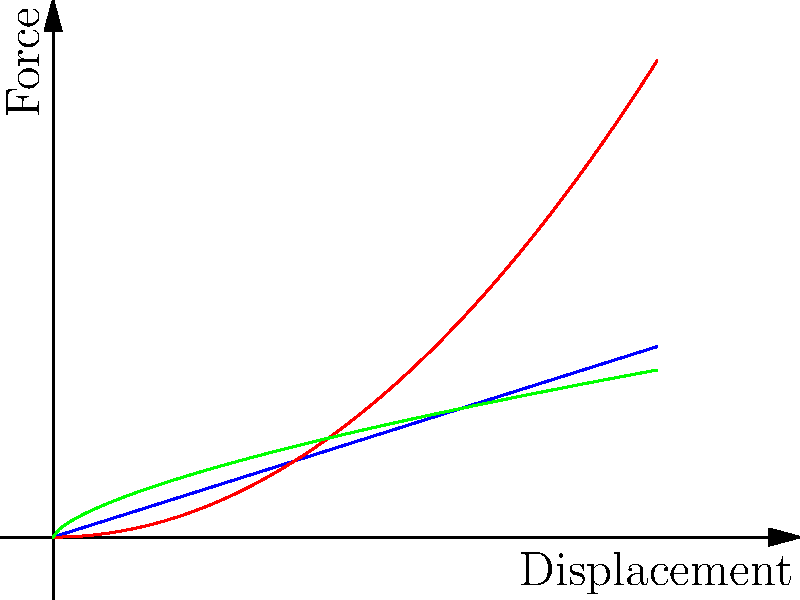Analyzing the force-displacement curves presented in the graph, which spring configuration would be most suitable for a progressive suspension system in a high-performance vehicle, where a softer initial response is desired for comfort, but a stiffer response is needed at higher loads to prevent bottoming out? To answer this question, we need to analyze the characteristics of each curve:

1. Linear (blue): This represents a standard spring with a constant spring rate. The force increases linearly with displacement.

2. Quadratic (red): This curve shows a progressive increase in force as displacement increases. The rate of change (slope) increases with displacement.

3. Power Law (green): This curve also shows a progressive increase, but with a different rate of change compared to the quadratic curve.

For a progressive suspension system:

a) Initial softer response: We want a curve that starts with a lower slope, providing a softer feel for small displacements.

b) Stiffer at higher loads: The curve should have an increasing slope as displacement increases, providing more resistance at higher loads.

Analyzing the curves:
- The linear spring doesn't meet our requirements as it has a constant rate.
- The quadratic curve starts soft but becomes very stiff quickly, which might be too extreme.
- The power law curve (green) provides a good balance: it starts with a lower slope for small displacements (softer initial response) and gradually increases in stiffness, but not as extremely as the quadratic curve.

Therefore, the power law curve (green) best meets the requirements for a progressive suspension system in this scenario.
Answer: Power Law (green) curve 